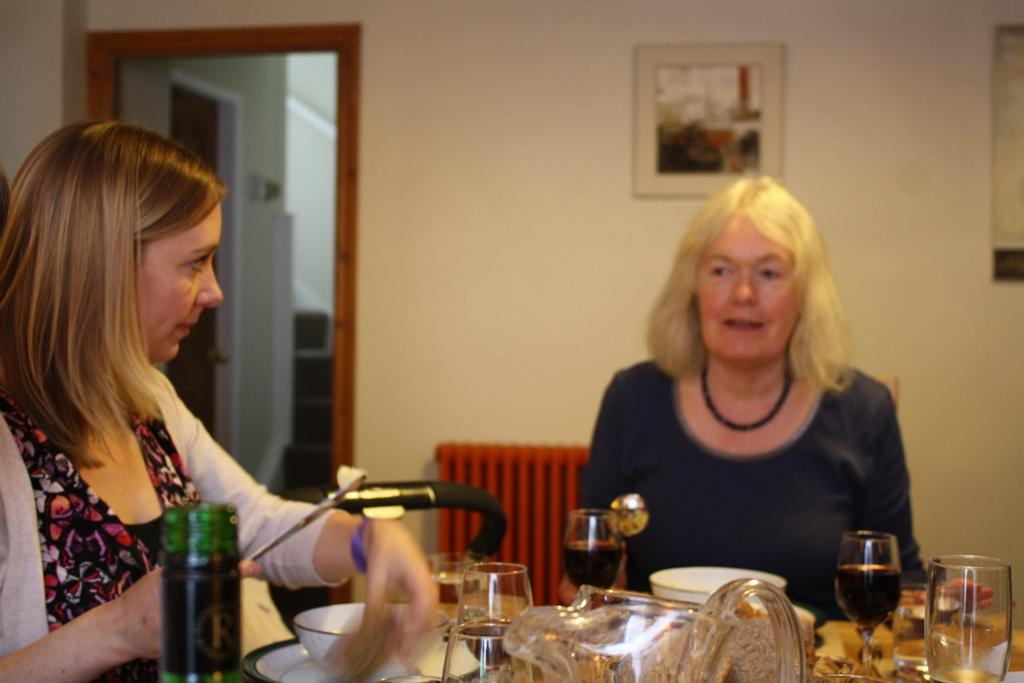How many women are in the image? There are two women in the image. What are the women doing in the image? The women are sitting on chairs. What is in front of the women? There is a table in front of the women. What items can be seen on the table? There are glasses, a bowl, a bottle, and a plate on the table. What is on the wall in the image? There is a picture on the wall. How many eggs are on the table in the image? There are no eggs present on the table in the image. Which direction is the north in relation to the women in the image? The image does not provide any information about the direction or orientation of the women, so it is impossible to determine which direction is north. 